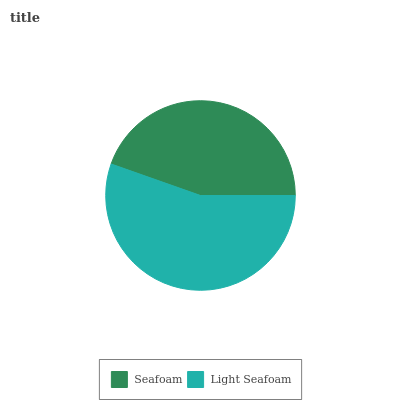Is Seafoam the minimum?
Answer yes or no. Yes. Is Light Seafoam the maximum?
Answer yes or no. Yes. Is Light Seafoam the minimum?
Answer yes or no. No. Is Light Seafoam greater than Seafoam?
Answer yes or no. Yes. Is Seafoam less than Light Seafoam?
Answer yes or no. Yes. Is Seafoam greater than Light Seafoam?
Answer yes or no. No. Is Light Seafoam less than Seafoam?
Answer yes or no. No. Is Light Seafoam the high median?
Answer yes or no. Yes. Is Seafoam the low median?
Answer yes or no. Yes. Is Seafoam the high median?
Answer yes or no. No. Is Light Seafoam the low median?
Answer yes or no. No. 